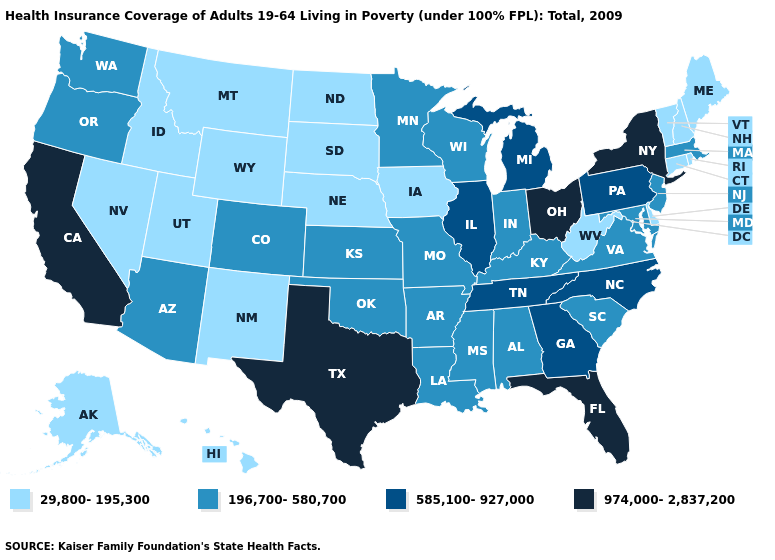Name the states that have a value in the range 29,800-195,300?
Answer briefly. Alaska, Connecticut, Delaware, Hawaii, Idaho, Iowa, Maine, Montana, Nebraska, Nevada, New Hampshire, New Mexico, North Dakota, Rhode Island, South Dakota, Utah, Vermont, West Virginia, Wyoming. What is the value of Pennsylvania?
Short answer required. 585,100-927,000. Name the states that have a value in the range 196,700-580,700?
Keep it brief. Alabama, Arizona, Arkansas, Colorado, Indiana, Kansas, Kentucky, Louisiana, Maryland, Massachusetts, Minnesota, Mississippi, Missouri, New Jersey, Oklahoma, Oregon, South Carolina, Virginia, Washington, Wisconsin. What is the value of North Carolina?
Quick response, please. 585,100-927,000. Among the states that border Delaware , which have the highest value?
Give a very brief answer. Pennsylvania. Is the legend a continuous bar?
Short answer required. No. Name the states that have a value in the range 585,100-927,000?
Concise answer only. Georgia, Illinois, Michigan, North Carolina, Pennsylvania, Tennessee. Which states have the lowest value in the USA?
Short answer required. Alaska, Connecticut, Delaware, Hawaii, Idaho, Iowa, Maine, Montana, Nebraska, Nevada, New Hampshire, New Mexico, North Dakota, Rhode Island, South Dakota, Utah, Vermont, West Virginia, Wyoming. Among the states that border Nebraska , does Iowa have the lowest value?
Short answer required. Yes. What is the value of Kentucky?
Be succinct. 196,700-580,700. Name the states that have a value in the range 29,800-195,300?
Keep it brief. Alaska, Connecticut, Delaware, Hawaii, Idaho, Iowa, Maine, Montana, Nebraska, Nevada, New Hampshire, New Mexico, North Dakota, Rhode Island, South Dakota, Utah, Vermont, West Virginia, Wyoming. Does Washington have the highest value in the West?
Answer briefly. No. Name the states that have a value in the range 974,000-2,837,200?
Answer briefly. California, Florida, New York, Ohio, Texas. Name the states that have a value in the range 29,800-195,300?
Give a very brief answer. Alaska, Connecticut, Delaware, Hawaii, Idaho, Iowa, Maine, Montana, Nebraska, Nevada, New Hampshire, New Mexico, North Dakota, Rhode Island, South Dakota, Utah, Vermont, West Virginia, Wyoming. 